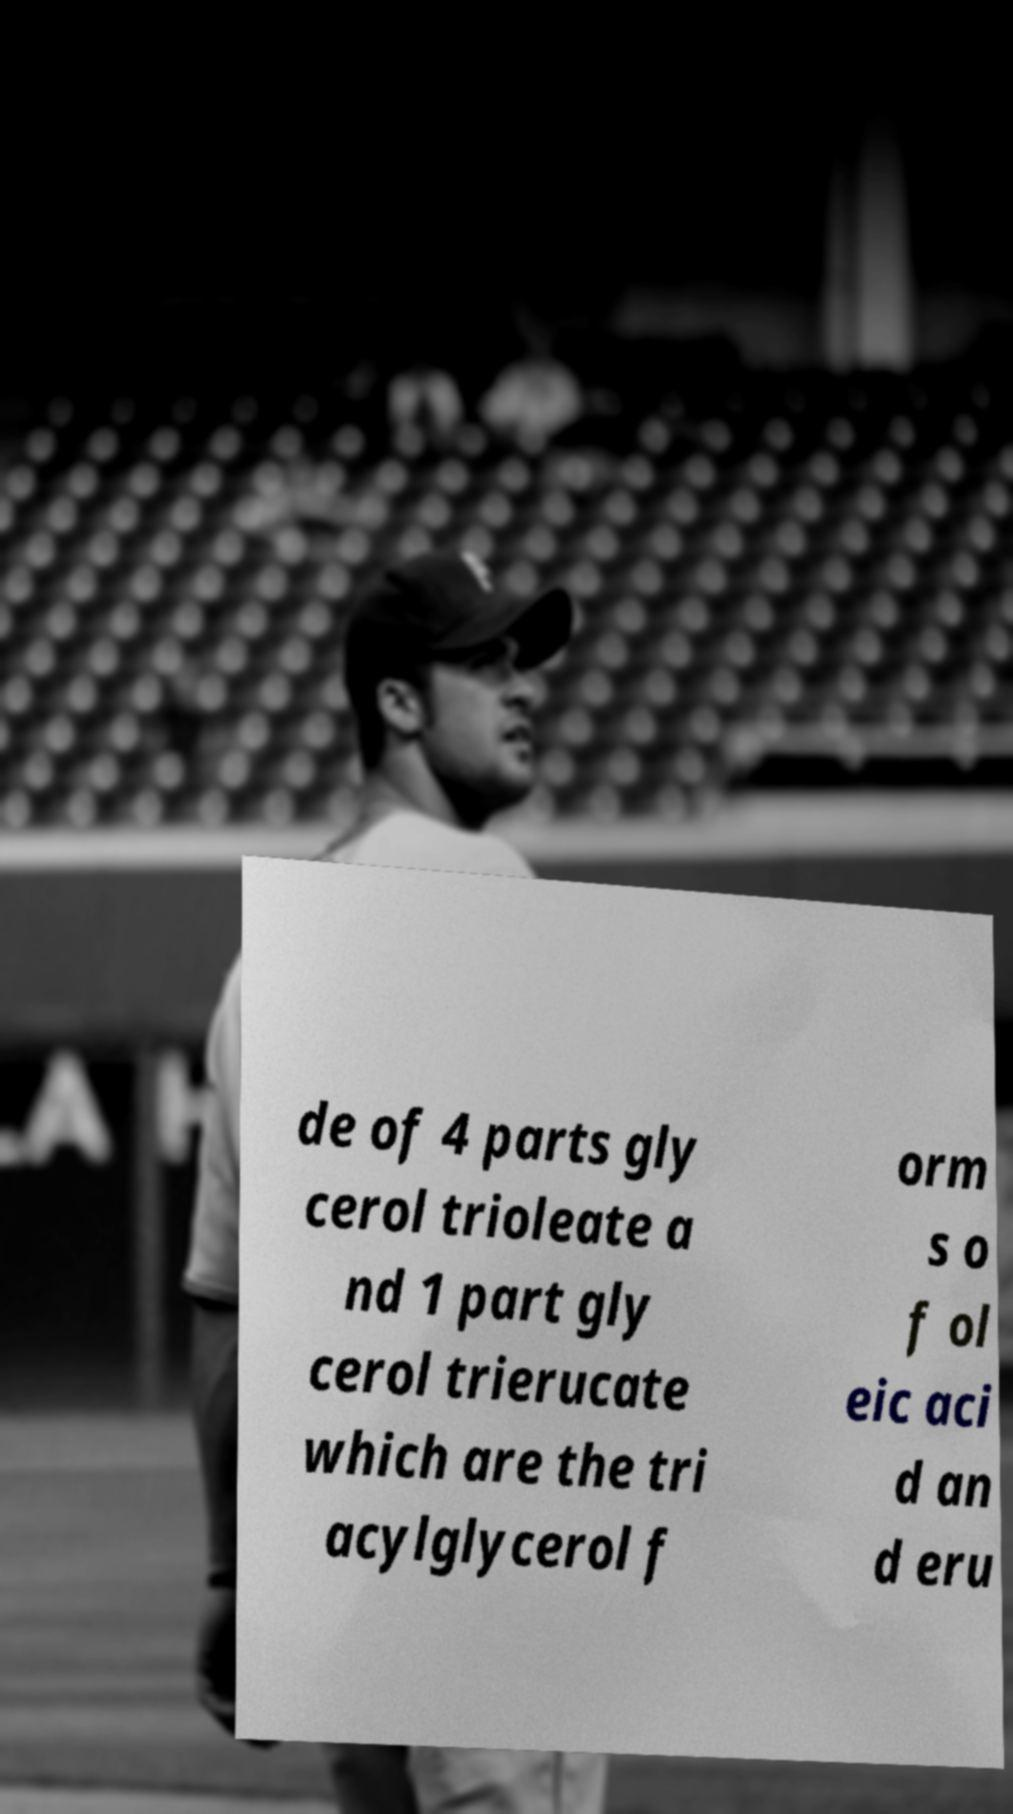I need the written content from this picture converted into text. Can you do that? de of 4 parts gly cerol trioleate a nd 1 part gly cerol trierucate which are the tri acylglycerol f orm s o f ol eic aci d an d eru 